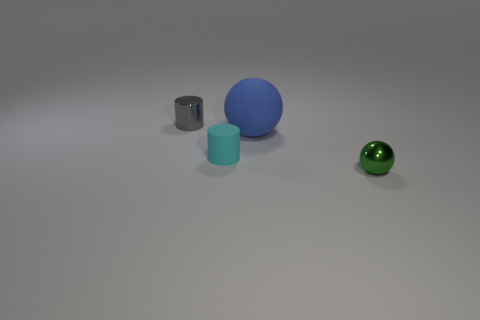What shape is the blue rubber object on the left side of the sphere in front of the tiny cylinder that is on the right side of the small gray shiny object?
Keep it short and to the point. Sphere. How many objects are either tiny shiny things that are to the left of the blue matte object or tiny shiny objects in front of the gray thing?
Provide a short and direct response. 2. There is a tiny cyan matte object; are there any blue matte spheres in front of it?
Keep it short and to the point. No. How many things are blue rubber spheres that are right of the small gray metallic cylinder or large purple rubber blocks?
Provide a short and direct response. 1. How many gray things are small metal balls or rubber cylinders?
Make the answer very short. 0. How many other objects are there of the same color as the metal ball?
Provide a short and direct response. 0. Is the number of small cyan rubber cylinders that are in front of the tiny cyan cylinder less than the number of red cylinders?
Provide a succinct answer. No. There is a small object that is behind the cylinder that is right of the tiny metal thing that is behind the tiny rubber thing; what color is it?
Give a very brief answer. Gray. The blue matte object that is the same shape as the green metal object is what size?
Provide a succinct answer. Large. Is the number of green shiny things that are behind the large blue matte ball less than the number of tiny shiny cylinders on the left side of the green thing?
Provide a succinct answer. Yes. 